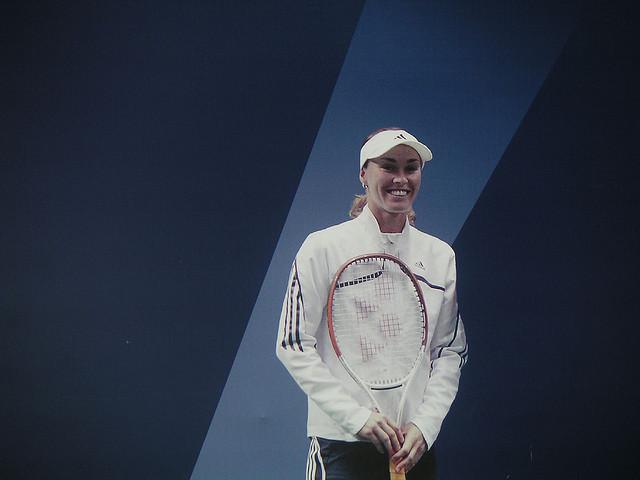Is the woman trying to hit a ball?
Write a very short answer. No. What type of sport is associated with this scene?
Give a very brief answer. Tennis. Is the woman smiling?
Keep it brief. Yes. What is the woman wearing?
Answer briefly. Jacket. 